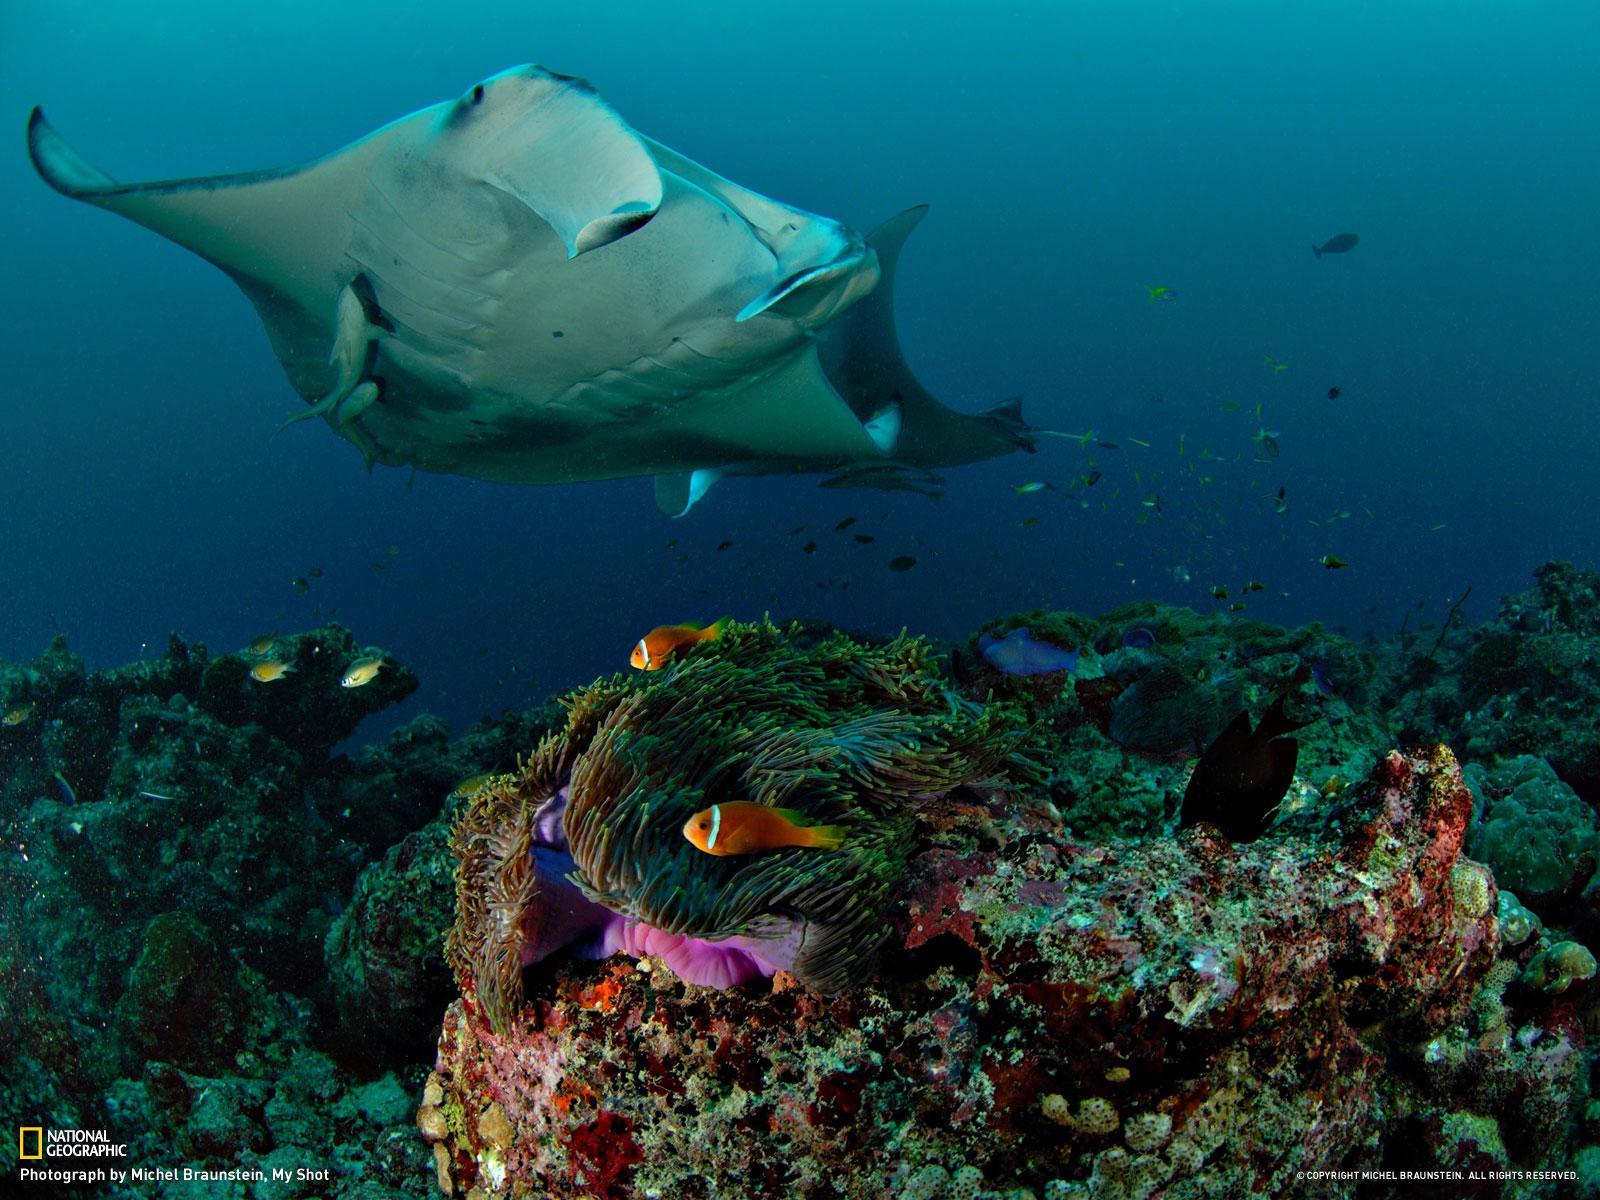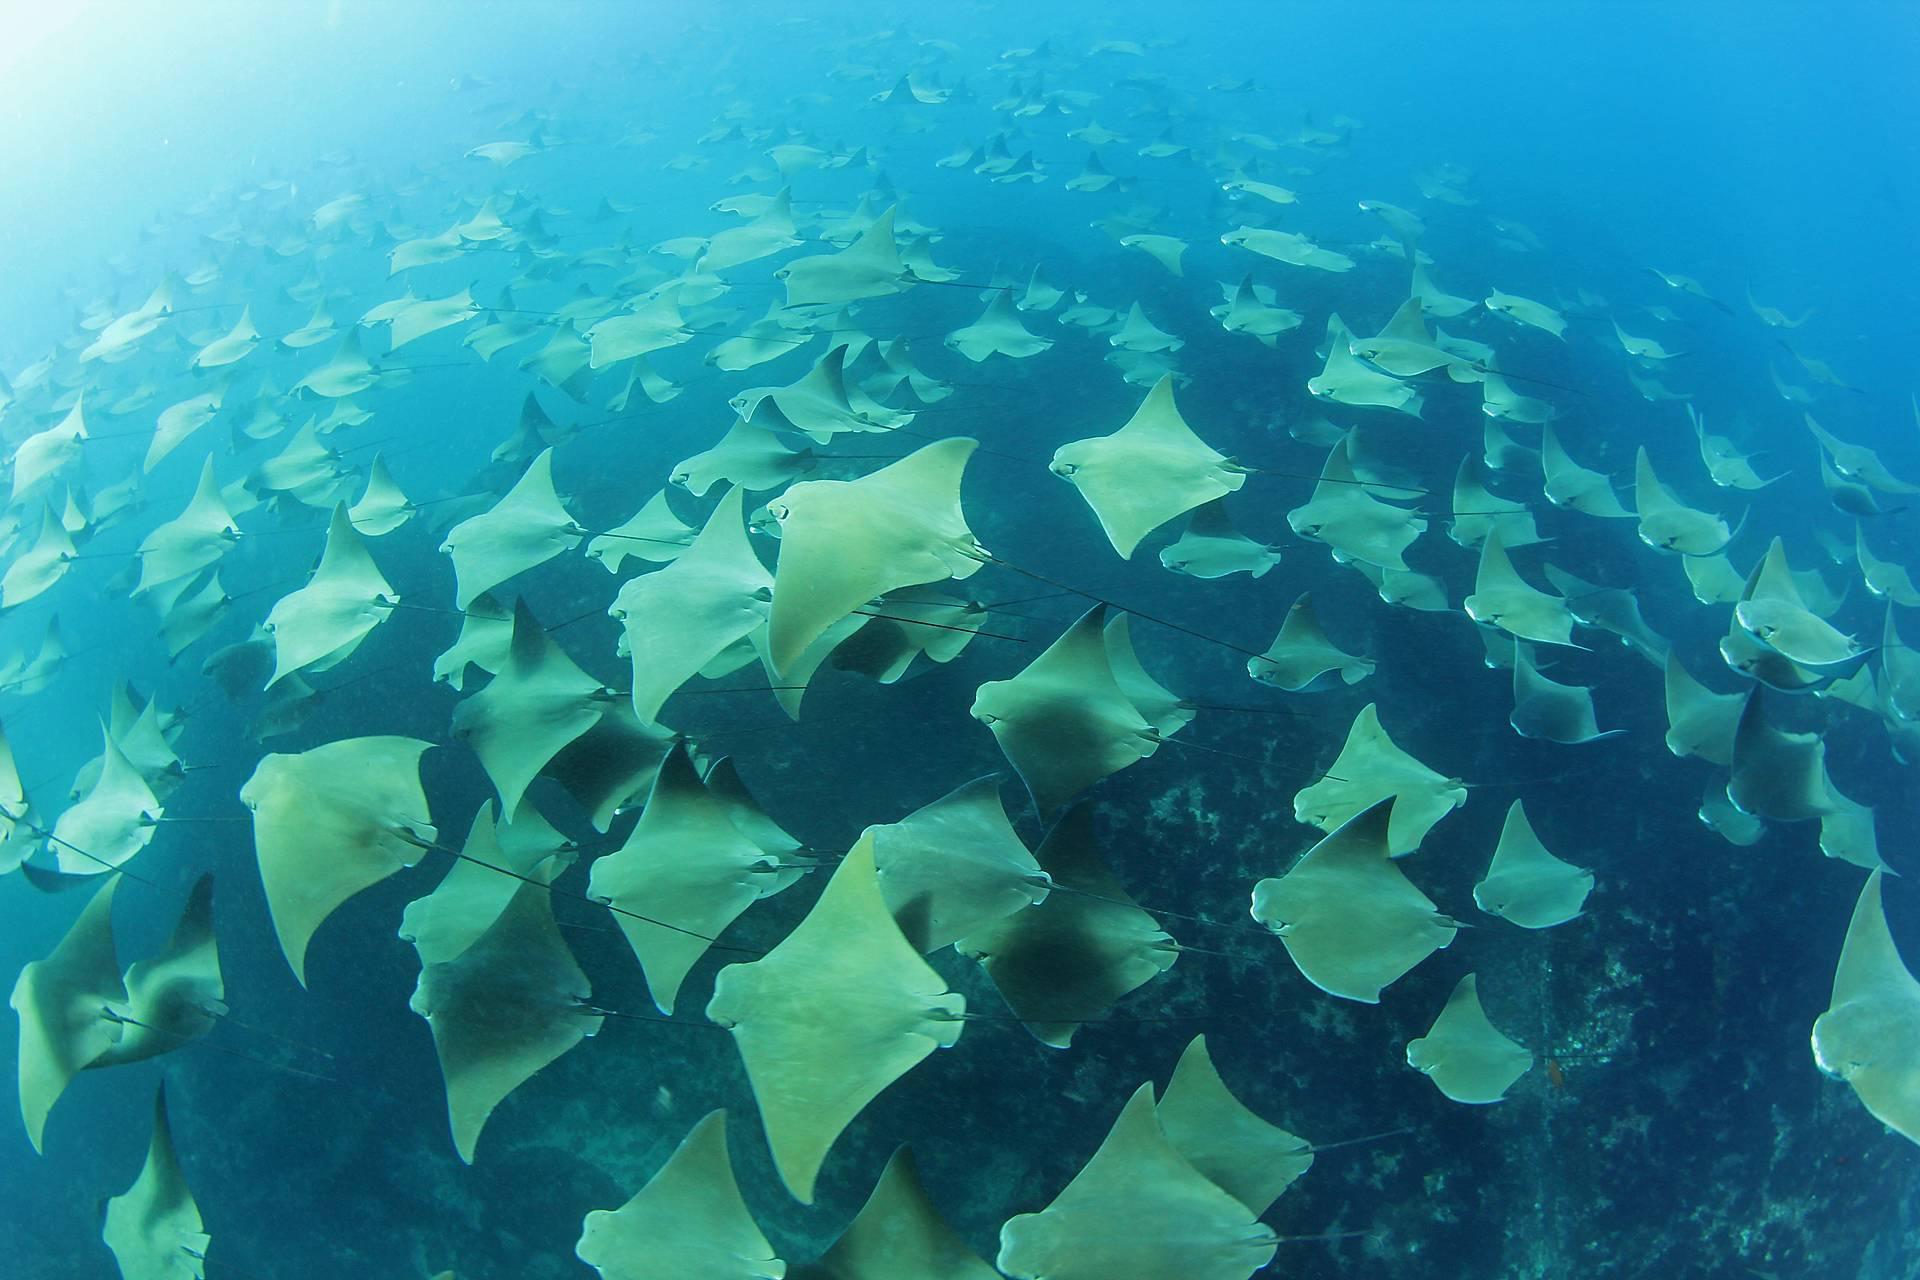The first image is the image on the left, the second image is the image on the right. For the images shown, is this caption "The image on the right contains one human swimming underwater." true? Answer yes or no. No. The first image is the image on the left, the second image is the image on the right. Evaluate the accuracy of this statement regarding the images: "There are less than five fish visible.". Is it true? Answer yes or no. No. 